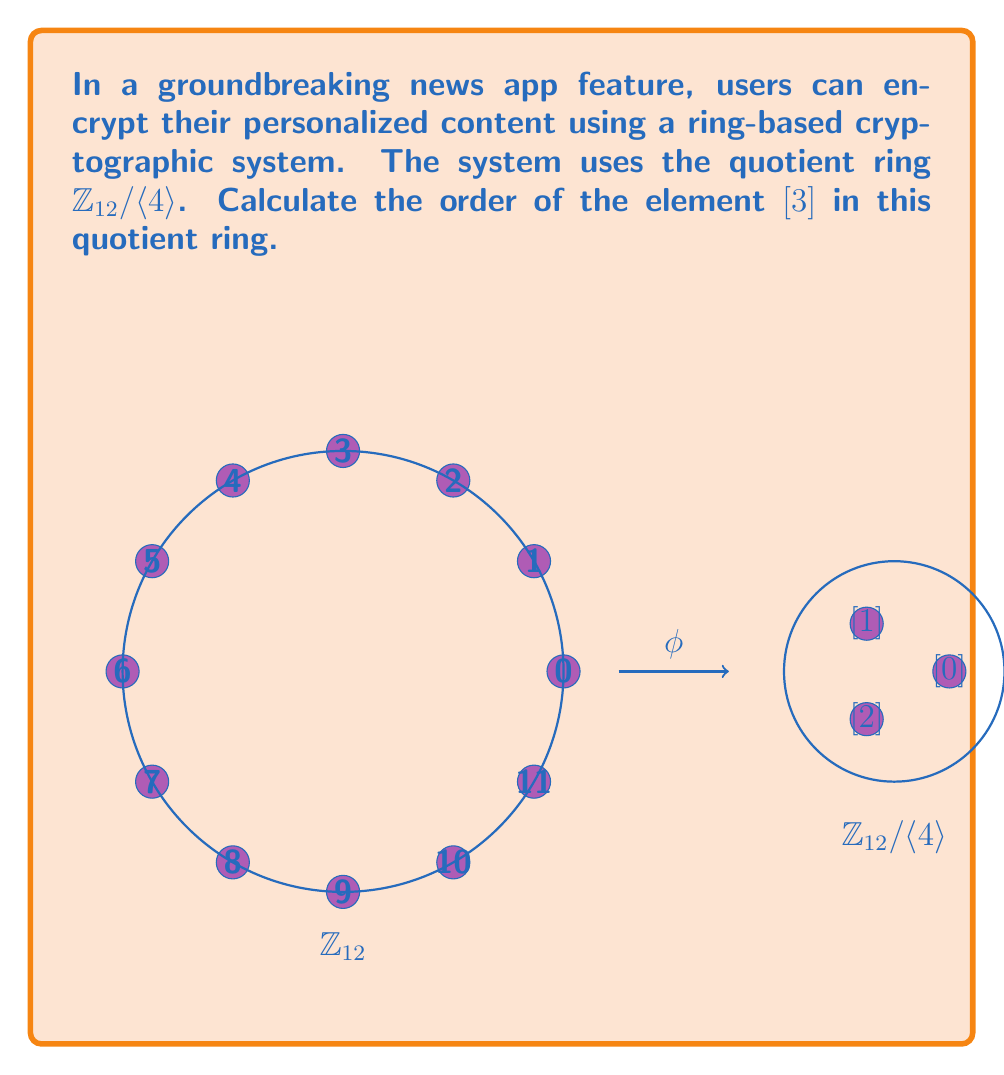Can you solve this math problem? To calculate the order of $[3]$ in $\mathbb{Z}_{12}/\langle 4 \rangle$, we need to follow these steps:

1) First, recall that in a quotient ring $\mathbb{Z}_n/\langle d \rangle$, where $d|n$, the order of the ring is $n/d$.

2) In this case, $n=12$ and $d=4$, so the order of $\mathbb{Z}_{12}/\langle 4 \rangle$ is $12/4 = 3$.

3) The elements of $\mathbb{Z}_{12}/\langle 4 \rangle$ are $[0], [1], [2]$.

4) To find the order of $[3]$, we need to find the smallest positive integer $k$ such that $k[3] = [0]$ in $\mathbb{Z}_{12}/\langle 4 \rangle$.

5) Let's compute the multiples of $[3]$:
   $1[3] = [3]$
   $2[3] = [6]$
   $3[3] = [9] = [1]$
   $4[3] = [12] = [0]$

6) We see that $4[3] = [0]$, and this is the smallest positive integer that gives us $[0]$.

7) Therefore, the order of $[3]$ in $\mathbb{Z}_{12}/\langle 4 \rangle$ is 4.

This means that in the news app's cryptographic system, the element $[3]$ will cycle through all values four times before returning to its starting point.
Answer: 4 